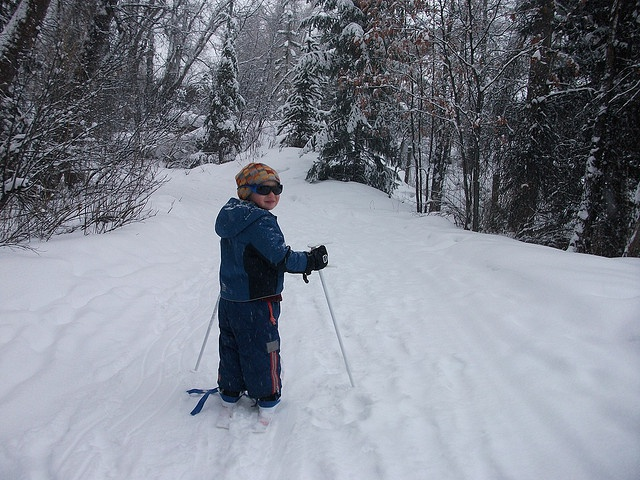Describe the objects in this image and their specific colors. I can see people in black, navy, gray, and lightgray tones and skis in black, darkgray, and gray tones in this image. 